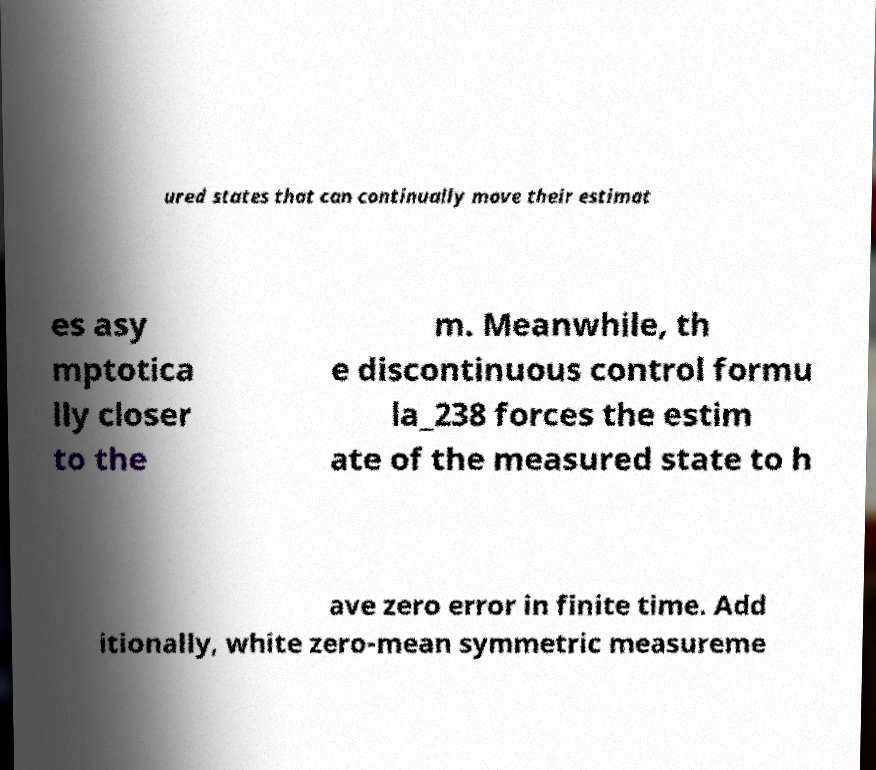Please read and relay the text visible in this image. What does it say? ured states that can continually move their estimat es asy mptotica lly closer to the m. Meanwhile, th e discontinuous control formu la_238 forces the estim ate of the measured state to h ave zero error in finite time. Add itionally, white zero-mean symmetric measureme 